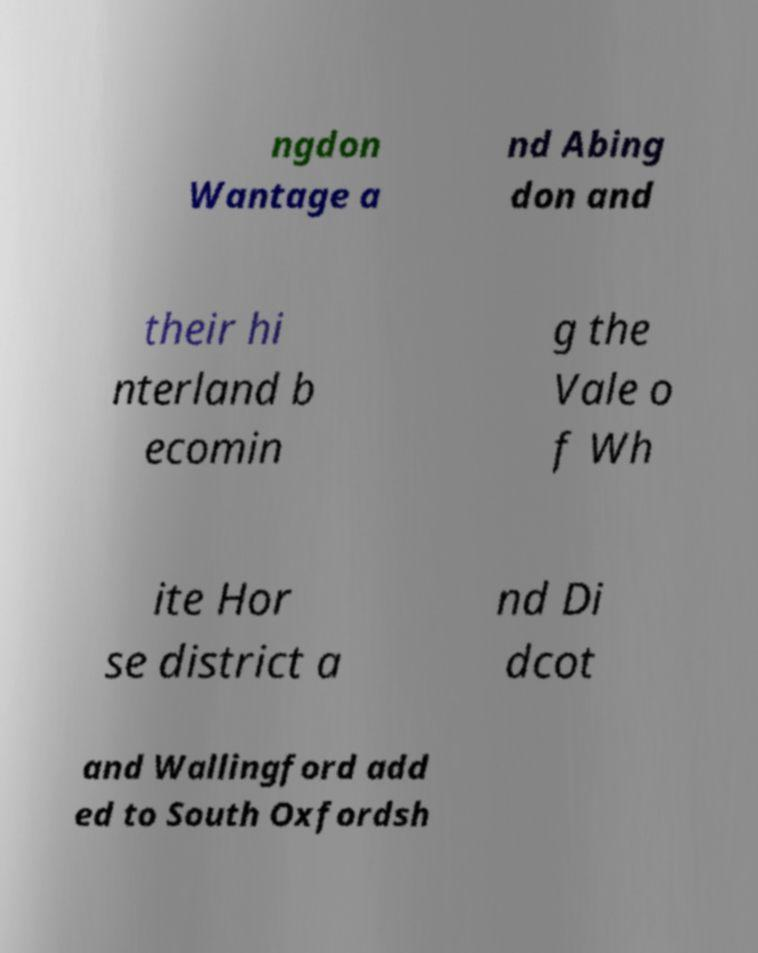For documentation purposes, I need the text within this image transcribed. Could you provide that? ngdon Wantage a nd Abing don and their hi nterland b ecomin g the Vale o f Wh ite Hor se district a nd Di dcot and Wallingford add ed to South Oxfordsh 